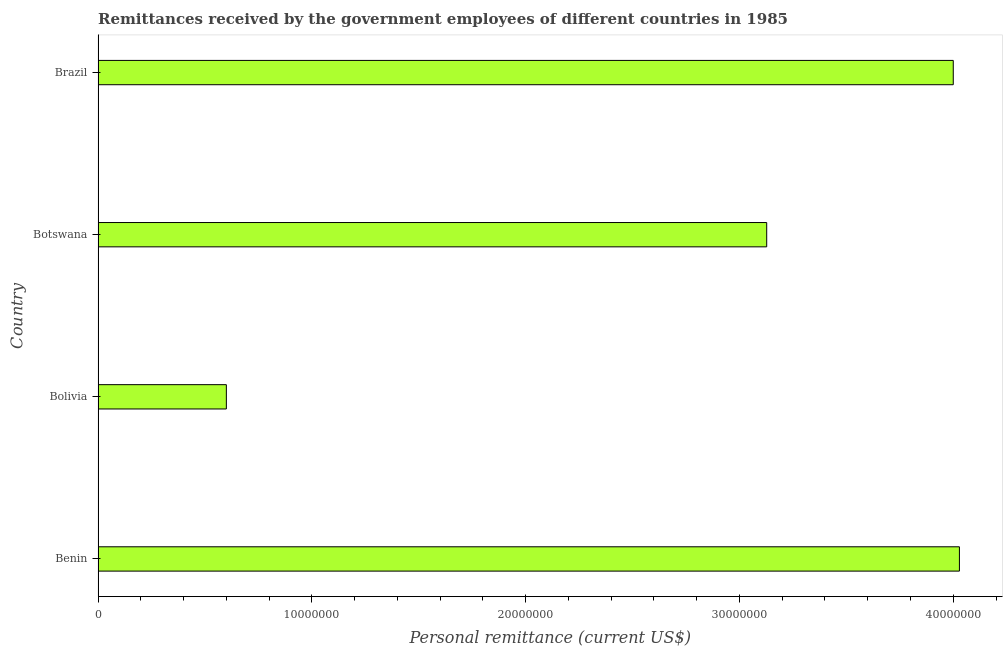What is the title of the graph?
Keep it short and to the point. Remittances received by the government employees of different countries in 1985. What is the label or title of the X-axis?
Your answer should be very brief. Personal remittance (current US$). What is the label or title of the Y-axis?
Offer a terse response. Country. What is the personal remittances in Botswana?
Provide a short and direct response. 3.13e+07. Across all countries, what is the maximum personal remittances?
Your answer should be compact. 4.03e+07. Across all countries, what is the minimum personal remittances?
Your response must be concise. 6.00e+06. In which country was the personal remittances maximum?
Provide a short and direct response. Benin. What is the sum of the personal remittances?
Make the answer very short. 1.18e+08. What is the difference between the personal remittances in Benin and Brazil?
Offer a very short reply. 2.88e+05. What is the average personal remittances per country?
Provide a succinct answer. 2.94e+07. What is the median personal remittances?
Make the answer very short. 3.56e+07. In how many countries, is the personal remittances greater than 10000000 US$?
Provide a short and direct response. 3. What is the ratio of the personal remittances in Benin to that in Botswana?
Your answer should be compact. 1.29. Is the personal remittances in Bolivia less than that in Botswana?
Provide a succinct answer. Yes. What is the difference between the highest and the second highest personal remittances?
Give a very brief answer. 2.88e+05. Is the sum of the personal remittances in Bolivia and Brazil greater than the maximum personal remittances across all countries?
Offer a very short reply. Yes. What is the difference between the highest and the lowest personal remittances?
Offer a terse response. 3.43e+07. How many bars are there?
Provide a short and direct response. 4. Are all the bars in the graph horizontal?
Make the answer very short. Yes. What is the difference between two consecutive major ticks on the X-axis?
Your answer should be very brief. 1.00e+07. What is the Personal remittance (current US$) in Benin?
Your answer should be compact. 4.03e+07. What is the Personal remittance (current US$) of Botswana?
Provide a succinct answer. 3.13e+07. What is the Personal remittance (current US$) in Brazil?
Your response must be concise. 4.00e+07. What is the difference between the Personal remittance (current US$) in Benin and Bolivia?
Make the answer very short. 3.43e+07. What is the difference between the Personal remittance (current US$) in Benin and Botswana?
Make the answer very short. 9.01e+06. What is the difference between the Personal remittance (current US$) in Benin and Brazil?
Offer a very short reply. 2.88e+05. What is the difference between the Personal remittance (current US$) in Bolivia and Botswana?
Ensure brevity in your answer.  -2.53e+07. What is the difference between the Personal remittance (current US$) in Bolivia and Brazil?
Your answer should be very brief. -3.40e+07. What is the difference between the Personal remittance (current US$) in Botswana and Brazil?
Your response must be concise. -8.73e+06. What is the ratio of the Personal remittance (current US$) in Benin to that in Bolivia?
Offer a very short reply. 6.71. What is the ratio of the Personal remittance (current US$) in Benin to that in Botswana?
Your answer should be very brief. 1.29. What is the ratio of the Personal remittance (current US$) in Bolivia to that in Botswana?
Offer a terse response. 0.19. What is the ratio of the Personal remittance (current US$) in Botswana to that in Brazil?
Ensure brevity in your answer.  0.78. 